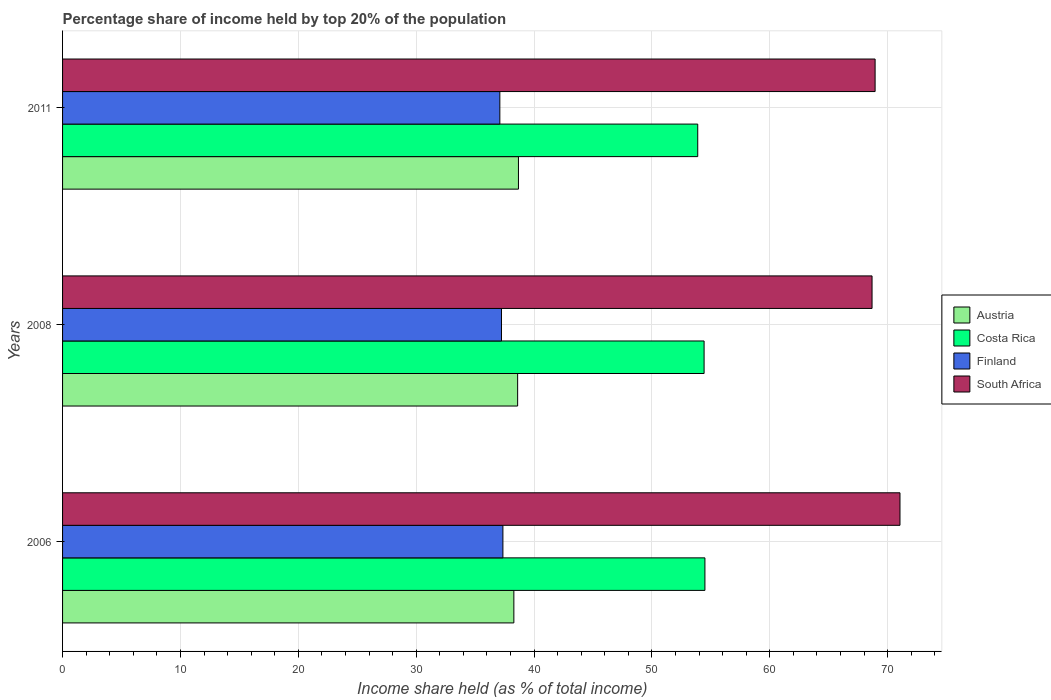How many groups of bars are there?
Make the answer very short. 3. Are the number of bars on each tick of the Y-axis equal?
Your answer should be very brief. Yes. What is the label of the 3rd group of bars from the top?
Provide a short and direct response. 2006. In how many cases, is the number of bars for a given year not equal to the number of legend labels?
Offer a terse response. 0. What is the percentage share of income held by top 20% of the population in Costa Rica in 2006?
Your answer should be very brief. 54.5. Across all years, what is the maximum percentage share of income held by top 20% of the population in Austria?
Provide a succinct answer. 38.68. Across all years, what is the minimum percentage share of income held by top 20% of the population in South Africa?
Keep it short and to the point. 68.68. In which year was the percentage share of income held by top 20% of the population in Austria minimum?
Provide a succinct answer. 2006. What is the total percentage share of income held by top 20% of the population in South Africa in the graph?
Make the answer very short. 208.67. What is the difference between the percentage share of income held by top 20% of the population in South Africa in 2006 and that in 2011?
Offer a terse response. 2.11. What is the difference between the percentage share of income held by top 20% of the population in Austria in 2006 and the percentage share of income held by top 20% of the population in Finland in 2011?
Offer a terse response. 1.19. What is the average percentage share of income held by top 20% of the population in Finland per year?
Your response must be concise. 37.23. In the year 2008, what is the difference between the percentage share of income held by top 20% of the population in South Africa and percentage share of income held by top 20% of the population in Costa Rica?
Your response must be concise. 14.25. What is the ratio of the percentage share of income held by top 20% of the population in Costa Rica in 2008 to that in 2011?
Your answer should be very brief. 1.01. Is the difference between the percentage share of income held by top 20% of the population in South Africa in 2008 and 2011 greater than the difference between the percentage share of income held by top 20% of the population in Costa Rica in 2008 and 2011?
Offer a very short reply. No. What is the difference between the highest and the second highest percentage share of income held by top 20% of the population in Costa Rica?
Your answer should be very brief. 0.07. What is the difference between the highest and the lowest percentage share of income held by top 20% of the population in Finland?
Make the answer very short. 0.26. In how many years, is the percentage share of income held by top 20% of the population in Austria greater than the average percentage share of income held by top 20% of the population in Austria taken over all years?
Make the answer very short. 2. Is the sum of the percentage share of income held by top 20% of the population in Finland in 2008 and 2011 greater than the maximum percentage share of income held by top 20% of the population in Austria across all years?
Make the answer very short. Yes. What does the 4th bar from the top in 2006 represents?
Make the answer very short. Austria. What does the 1st bar from the bottom in 2008 represents?
Provide a succinct answer. Austria. Is it the case that in every year, the sum of the percentage share of income held by top 20% of the population in Costa Rica and percentage share of income held by top 20% of the population in Austria is greater than the percentage share of income held by top 20% of the population in South Africa?
Provide a short and direct response. Yes. How many years are there in the graph?
Your answer should be very brief. 3. Where does the legend appear in the graph?
Provide a succinct answer. Center right. What is the title of the graph?
Make the answer very short. Percentage share of income held by top 20% of the population. Does "Mali" appear as one of the legend labels in the graph?
Ensure brevity in your answer.  No. What is the label or title of the X-axis?
Keep it short and to the point. Income share held (as % of total income). What is the label or title of the Y-axis?
Ensure brevity in your answer.  Years. What is the Income share held (as % of total income) in Austria in 2006?
Provide a succinct answer. 38.29. What is the Income share held (as % of total income) in Costa Rica in 2006?
Provide a short and direct response. 54.5. What is the Income share held (as % of total income) of Finland in 2006?
Provide a succinct answer. 37.36. What is the Income share held (as % of total income) in South Africa in 2006?
Provide a succinct answer. 71.05. What is the Income share held (as % of total income) in Austria in 2008?
Ensure brevity in your answer.  38.61. What is the Income share held (as % of total income) of Costa Rica in 2008?
Give a very brief answer. 54.43. What is the Income share held (as % of total income) in Finland in 2008?
Offer a very short reply. 37.24. What is the Income share held (as % of total income) of South Africa in 2008?
Give a very brief answer. 68.68. What is the Income share held (as % of total income) in Austria in 2011?
Offer a terse response. 38.68. What is the Income share held (as % of total income) in Costa Rica in 2011?
Offer a very short reply. 53.89. What is the Income share held (as % of total income) in Finland in 2011?
Keep it short and to the point. 37.1. What is the Income share held (as % of total income) in South Africa in 2011?
Your answer should be compact. 68.94. Across all years, what is the maximum Income share held (as % of total income) of Austria?
Ensure brevity in your answer.  38.68. Across all years, what is the maximum Income share held (as % of total income) of Costa Rica?
Give a very brief answer. 54.5. Across all years, what is the maximum Income share held (as % of total income) of Finland?
Your answer should be very brief. 37.36. Across all years, what is the maximum Income share held (as % of total income) in South Africa?
Keep it short and to the point. 71.05. Across all years, what is the minimum Income share held (as % of total income) of Austria?
Ensure brevity in your answer.  38.29. Across all years, what is the minimum Income share held (as % of total income) in Costa Rica?
Ensure brevity in your answer.  53.89. Across all years, what is the minimum Income share held (as % of total income) in Finland?
Provide a succinct answer. 37.1. Across all years, what is the minimum Income share held (as % of total income) of South Africa?
Make the answer very short. 68.68. What is the total Income share held (as % of total income) in Austria in the graph?
Give a very brief answer. 115.58. What is the total Income share held (as % of total income) of Costa Rica in the graph?
Your answer should be compact. 162.82. What is the total Income share held (as % of total income) in Finland in the graph?
Your answer should be compact. 111.7. What is the total Income share held (as % of total income) in South Africa in the graph?
Offer a very short reply. 208.67. What is the difference between the Income share held (as % of total income) of Austria in 2006 and that in 2008?
Make the answer very short. -0.32. What is the difference between the Income share held (as % of total income) in Costa Rica in 2006 and that in 2008?
Ensure brevity in your answer.  0.07. What is the difference between the Income share held (as % of total income) in Finland in 2006 and that in 2008?
Your response must be concise. 0.12. What is the difference between the Income share held (as % of total income) of South Africa in 2006 and that in 2008?
Ensure brevity in your answer.  2.37. What is the difference between the Income share held (as % of total income) of Austria in 2006 and that in 2011?
Make the answer very short. -0.39. What is the difference between the Income share held (as % of total income) in Costa Rica in 2006 and that in 2011?
Keep it short and to the point. 0.61. What is the difference between the Income share held (as % of total income) in Finland in 2006 and that in 2011?
Provide a short and direct response. 0.26. What is the difference between the Income share held (as % of total income) in South Africa in 2006 and that in 2011?
Offer a very short reply. 2.11. What is the difference between the Income share held (as % of total income) of Austria in 2008 and that in 2011?
Keep it short and to the point. -0.07. What is the difference between the Income share held (as % of total income) in Costa Rica in 2008 and that in 2011?
Your answer should be compact. 0.54. What is the difference between the Income share held (as % of total income) of Finland in 2008 and that in 2011?
Offer a very short reply. 0.14. What is the difference between the Income share held (as % of total income) in South Africa in 2008 and that in 2011?
Your answer should be compact. -0.26. What is the difference between the Income share held (as % of total income) in Austria in 2006 and the Income share held (as % of total income) in Costa Rica in 2008?
Make the answer very short. -16.14. What is the difference between the Income share held (as % of total income) of Austria in 2006 and the Income share held (as % of total income) of Finland in 2008?
Your answer should be very brief. 1.05. What is the difference between the Income share held (as % of total income) in Austria in 2006 and the Income share held (as % of total income) in South Africa in 2008?
Make the answer very short. -30.39. What is the difference between the Income share held (as % of total income) in Costa Rica in 2006 and the Income share held (as % of total income) in Finland in 2008?
Give a very brief answer. 17.26. What is the difference between the Income share held (as % of total income) in Costa Rica in 2006 and the Income share held (as % of total income) in South Africa in 2008?
Provide a short and direct response. -14.18. What is the difference between the Income share held (as % of total income) of Finland in 2006 and the Income share held (as % of total income) of South Africa in 2008?
Give a very brief answer. -31.32. What is the difference between the Income share held (as % of total income) in Austria in 2006 and the Income share held (as % of total income) in Costa Rica in 2011?
Your response must be concise. -15.6. What is the difference between the Income share held (as % of total income) of Austria in 2006 and the Income share held (as % of total income) of Finland in 2011?
Make the answer very short. 1.19. What is the difference between the Income share held (as % of total income) of Austria in 2006 and the Income share held (as % of total income) of South Africa in 2011?
Offer a very short reply. -30.65. What is the difference between the Income share held (as % of total income) in Costa Rica in 2006 and the Income share held (as % of total income) in South Africa in 2011?
Give a very brief answer. -14.44. What is the difference between the Income share held (as % of total income) in Finland in 2006 and the Income share held (as % of total income) in South Africa in 2011?
Your answer should be compact. -31.58. What is the difference between the Income share held (as % of total income) of Austria in 2008 and the Income share held (as % of total income) of Costa Rica in 2011?
Offer a very short reply. -15.28. What is the difference between the Income share held (as % of total income) of Austria in 2008 and the Income share held (as % of total income) of Finland in 2011?
Make the answer very short. 1.51. What is the difference between the Income share held (as % of total income) of Austria in 2008 and the Income share held (as % of total income) of South Africa in 2011?
Provide a succinct answer. -30.33. What is the difference between the Income share held (as % of total income) of Costa Rica in 2008 and the Income share held (as % of total income) of Finland in 2011?
Your response must be concise. 17.33. What is the difference between the Income share held (as % of total income) of Costa Rica in 2008 and the Income share held (as % of total income) of South Africa in 2011?
Your answer should be compact. -14.51. What is the difference between the Income share held (as % of total income) of Finland in 2008 and the Income share held (as % of total income) of South Africa in 2011?
Your answer should be compact. -31.7. What is the average Income share held (as % of total income) in Austria per year?
Provide a succinct answer. 38.53. What is the average Income share held (as % of total income) in Costa Rica per year?
Make the answer very short. 54.27. What is the average Income share held (as % of total income) of Finland per year?
Your response must be concise. 37.23. What is the average Income share held (as % of total income) in South Africa per year?
Provide a short and direct response. 69.56. In the year 2006, what is the difference between the Income share held (as % of total income) in Austria and Income share held (as % of total income) in Costa Rica?
Your answer should be very brief. -16.21. In the year 2006, what is the difference between the Income share held (as % of total income) in Austria and Income share held (as % of total income) in Finland?
Make the answer very short. 0.93. In the year 2006, what is the difference between the Income share held (as % of total income) in Austria and Income share held (as % of total income) in South Africa?
Offer a terse response. -32.76. In the year 2006, what is the difference between the Income share held (as % of total income) of Costa Rica and Income share held (as % of total income) of Finland?
Provide a succinct answer. 17.14. In the year 2006, what is the difference between the Income share held (as % of total income) in Costa Rica and Income share held (as % of total income) in South Africa?
Your answer should be very brief. -16.55. In the year 2006, what is the difference between the Income share held (as % of total income) of Finland and Income share held (as % of total income) of South Africa?
Offer a very short reply. -33.69. In the year 2008, what is the difference between the Income share held (as % of total income) in Austria and Income share held (as % of total income) in Costa Rica?
Your answer should be very brief. -15.82. In the year 2008, what is the difference between the Income share held (as % of total income) of Austria and Income share held (as % of total income) of Finland?
Give a very brief answer. 1.37. In the year 2008, what is the difference between the Income share held (as % of total income) in Austria and Income share held (as % of total income) in South Africa?
Keep it short and to the point. -30.07. In the year 2008, what is the difference between the Income share held (as % of total income) of Costa Rica and Income share held (as % of total income) of Finland?
Offer a very short reply. 17.19. In the year 2008, what is the difference between the Income share held (as % of total income) of Costa Rica and Income share held (as % of total income) of South Africa?
Your answer should be compact. -14.25. In the year 2008, what is the difference between the Income share held (as % of total income) in Finland and Income share held (as % of total income) in South Africa?
Offer a terse response. -31.44. In the year 2011, what is the difference between the Income share held (as % of total income) in Austria and Income share held (as % of total income) in Costa Rica?
Offer a terse response. -15.21. In the year 2011, what is the difference between the Income share held (as % of total income) in Austria and Income share held (as % of total income) in Finland?
Keep it short and to the point. 1.58. In the year 2011, what is the difference between the Income share held (as % of total income) in Austria and Income share held (as % of total income) in South Africa?
Make the answer very short. -30.26. In the year 2011, what is the difference between the Income share held (as % of total income) in Costa Rica and Income share held (as % of total income) in Finland?
Provide a short and direct response. 16.79. In the year 2011, what is the difference between the Income share held (as % of total income) of Costa Rica and Income share held (as % of total income) of South Africa?
Keep it short and to the point. -15.05. In the year 2011, what is the difference between the Income share held (as % of total income) in Finland and Income share held (as % of total income) in South Africa?
Provide a succinct answer. -31.84. What is the ratio of the Income share held (as % of total income) of Austria in 2006 to that in 2008?
Your answer should be compact. 0.99. What is the ratio of the Income share held (as % of total income) of Costa Rica in 2006 to that in 2008?
Provide a short and direct response. 1. What is the ratio of the Income share held (as % of total income) in South Africa in 2006 to that in 2008?
Provide a short and direct response. 1.03. What is the ratio of the Income share held (as % of total income) in Austria in 2006 to that in 2011?
Provide a succinct answer. 0.99. What is the ratio of the Income share held (as % of total income) in Costa Rica in 2006 to that in 2011?
Keep it short and to the point. 1.01. What is the ratio of the Income share held (as % of total income) in Finland in 2006 to that in 2011?
Make the answer very short. 1.01. What is the ratio of the Income share held (as % of total income) in South Africa in 2006 to that in 2011?
Give a very brief answer. 1.03. What is the ratio of the Income share held (as % of total income) in Costa Rica in 2008 to that in 2011?
Your answer should be very brief. 1.01. What is the ratio of the Income share held (as % of total income) of South Africa in 2008 to that in 2011?
Give a very brief answer. 1. What is the difference between the highest and the second highest Income share held (as % of total income) in Austria?
Your response must be concise. 0.07. What is the difference between the highest and the second highest Income share held (as % of total income) in Costa Rica?
Offer a very short reply. 0.07. What is the difference between the highest and the second highest Income share held (as % of total income) in Finland?
Provide a short and direct response. 0.12. What is the difference between the highest and the second highest Income share held (as % of total income) of South Africa?
Make the answer very short. 2.11. What is the difference between the highest and the lowest Income share held (as % of total income) of Austria?
Keep it short and to the point. 0.39. What is the difference between the highest and the lowest Income share held (as % of total income) of Costa Rica?
Keep it short and to the point. 0.61. What is the difference between the highest and the lowest Income share held (as % of total income) in Finland?
Offer a very short reply. 0.26. What is the difference between the highest and the lowest Income share held (as % of total income) in South Africa?
Make the answer very short. 2.37. 